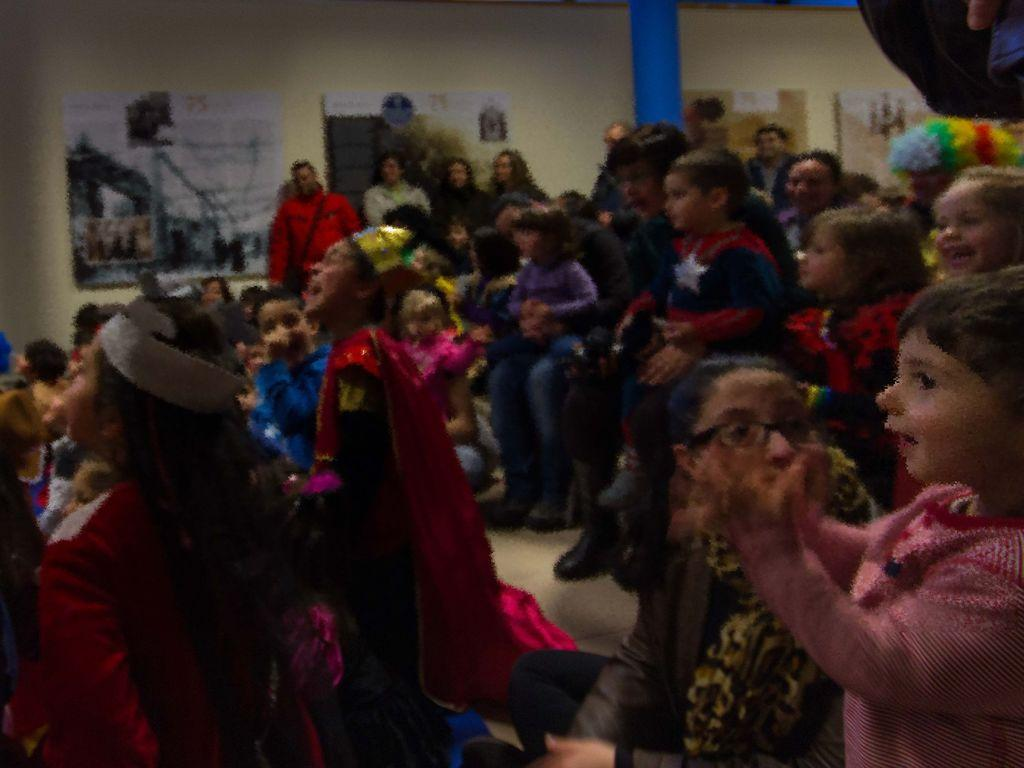What are the people in the image doing? There are people sitting and standing in the image. What can be seen on the wall in the image? There are posters on the wall in the image. What type of birds can be seen flying near the people in the image? There are no birds visible in the image. What kind of ray is emitting light from the wall in the image? There is no ray present in the image; it only features people, a wall, and posters. 